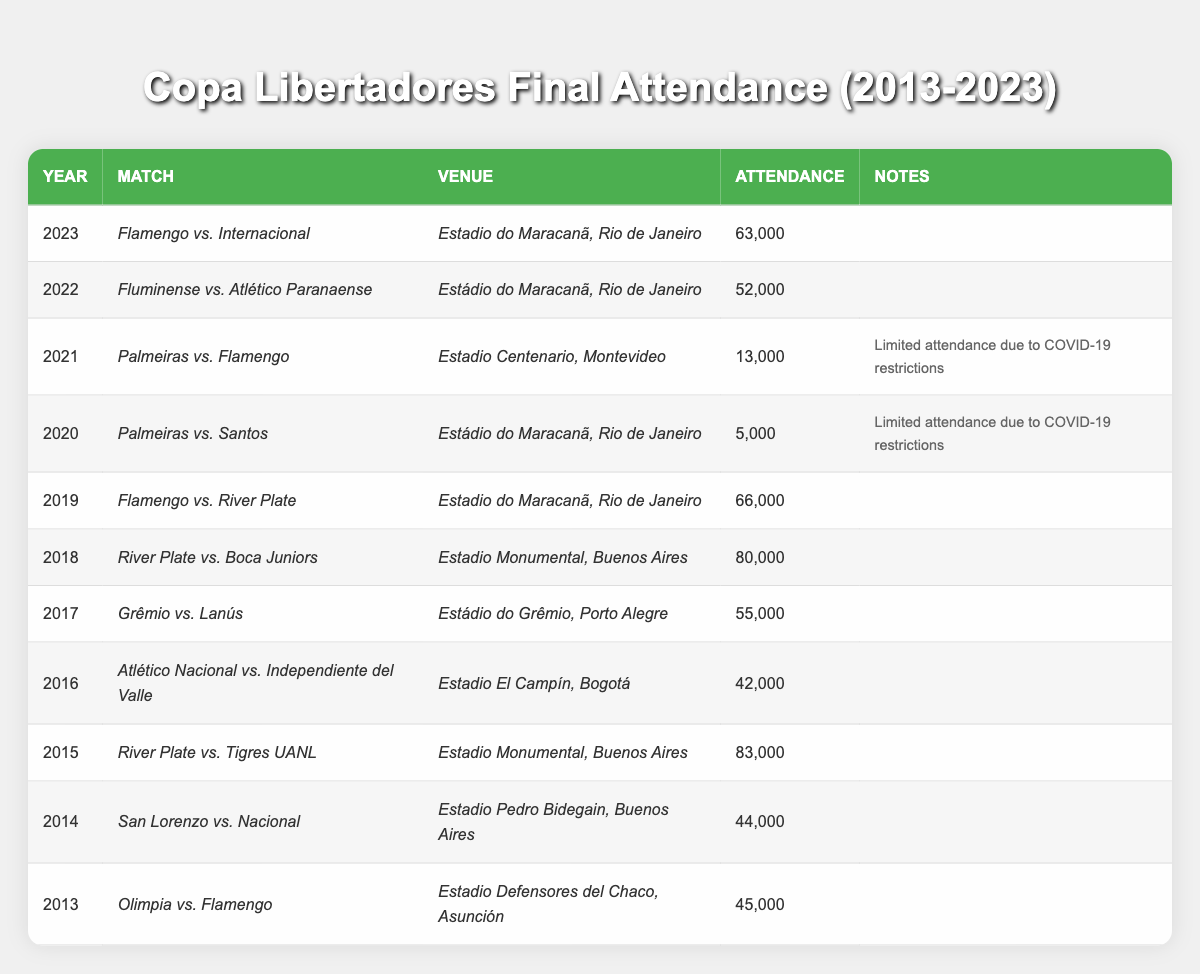What was the highest match attendance in the last decade of Copa Libertadores finals? The highest attendance in the table is 83,000 for the match "River Plate vs. Tigres UANL" in 2015.
Answer: 83,000 Which year had the lowest attendance at a Copa Libertadores final? The lowest attendance recorded is 5,000 in 2020 for the match "Palmeiras vs. Santos," due to COVID-19 restrictions.
Answer: 5,000 What is the average attendance for Copa Libertadores finals from 2013 to 2023? The sum of attendances from 2013 to 2023 is (45000 + 44000 + 83000 + 42000 + 55000 + 80000 + 66000 + 5000 + 13000 + 52000 + 63000) = 516,000. There are 11 data points, so the average is 516,000/11 ≈ 46,909.
Answer: 46,909 Did "River Plate vs. Boca Juniors" in 2018 have more attendees than "Flamengo vs. River Plate" in 2019? "River Plate vs. Boca Juniors" had 80,000 attendees while "Flamengo vs. River Plate" had 66,000 attendees. Since 80,000 > 66,000, the statement is true.
Answer: Yes How many finals had an attendance of over 60,000 in the last decade? The matches with attendance over 60,000 are: "River Plate vs. Tigres UANL" (83,000), "River Plate vs. Boca Juniors" (80,000), "Flamengo vs. River Plate" (66,000), and "Flamengo vs. Internacional" (63,000). That's a total of 4 matches.
Answer: 4 What percentage of the finals from 2020 and 2021 had limited attendance due to COVID-19 restrictions? There were 2 finals in 2020 and 2021, both had limited attendance due to COVID-19 restrictions. Therefore, 2/2 * 100% = 100%.
Answer: 100% Which venue had the highest attendance for a Copa Libertadores final? The Estadio Monumental in Buenos Aires hosted the final with the highest attendance of 83,000 for the match between "River Plate vs. Tigres UANL" in 2015.
Answer: Estadio Monumental How did the attendance numbers change from the 2019 final to the 2020 final? The attendance decreased from 66,000 in 2019 to 5,000 in 2020. This is a change of 66,000 - 5,000 = 61,000, indicating a significant drop.
Answer: Decreased by 61,000 What was the average attendance for the finals held at the Estadio do Maracanã? The matches at Maracanã are: "Flamengo vs. River Plate" (66,000), "Palmeiras vs. Santos" (5,000), "Fluminense vs. Atlético Paranaense" (52,000), and "Flamengo vs. Internacional" (63,000). Sum = 66,000 + 5,000 + 52,000 + 63,000 = 186,000. With 4 matches, the average is 186,000/4 = 46,500.
Answer: 46,500 Were there more matches with attendance over 50,000 or under 50,000? The matches with over 50,000 are: "River Plate vs. Tigres UANL" (83,000), "River Plate vs. Boca Juniors" (80,000), "Flamengo vs. River Plate" (66,000), "Flamengo vs. Internacional" (63,000), and "Grêmio vs. Lanús" (55,000), totaling 5 matches. The matches under 50,000 are "Palmeiras vs. Santos" (5,000) and "Palmeiras vs. Flamengo" (13,000) totaling 2 matches. Thus, there are more matches over 50,000.
Answer: More matches over 50,000 